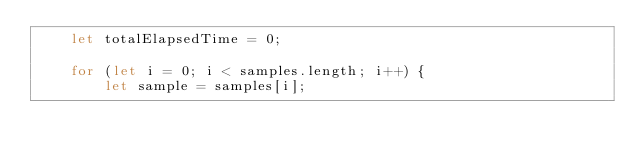Convert code to text. <code><loc_0><loc_0><loc_500><loc_500><_JavaScript_>    let totalElapsedTime = 0;

    for (let i = 0; i < samples.length; i++) {
        let sample = samples[i];</code> 